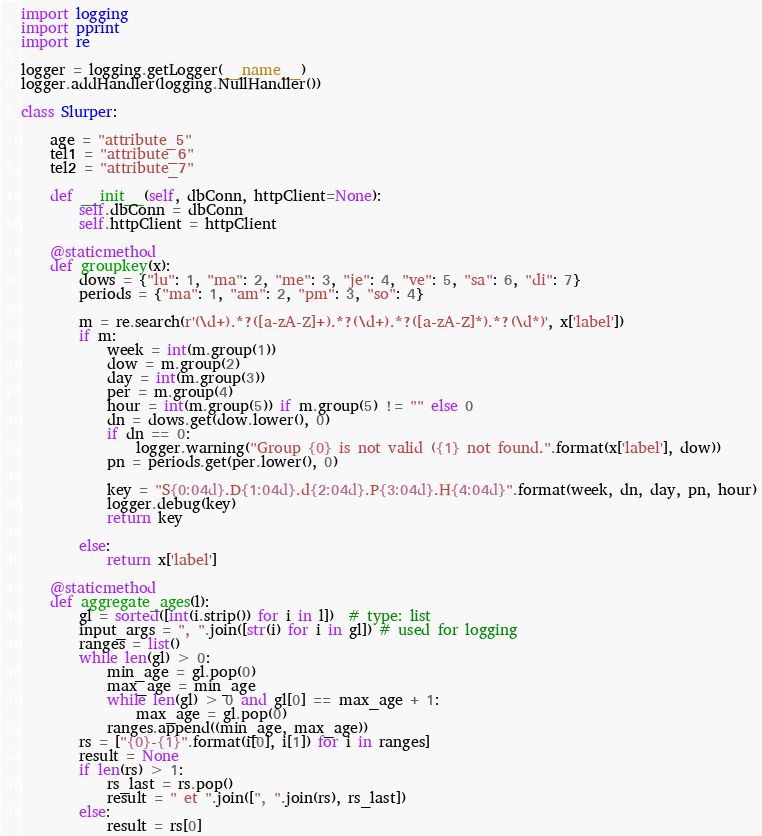Convert code to text. <code><loc_0><loc_0><loc_500><loc_500><_Python_>import logging
import pprint
import re

logger = logging.getLogger(__name__)
logger.addHandler(logging.NullHandler())

class Slurper:

    age = "attribute_5"
    tel1 = "attribute_6"
    tel2 = "attribute_7"

    def __init__(self, dbConn, httpClient=None):
        self.dbConn = dbConn
        self.httpClient = httpClient

    @staticmethod
    def groupkey(x):
        dows = {"lu": 1, "ma": 2, "me": 3, "je": 4, "ve": 5, "sa": 6, "di": 7}
        periods = {"ma": 1, "am": 2, "pm": 3, "so": 4}

        m = re.search(r'(\d+).*?([a-zA-Z]+).*?(\d+).*?([a-zA-Z]*).*?(\d*)', x['label'])
        if m:
            week = int(m.group(1))
            dow = m.group(2)
            day = int(m.group(3))
            per = m.group(4)
            hour = int(m.group(5)) if m.group(5) != "" else 0
            dn = dows.get(dow.lower(), 0)
            if dn == 0:
                logger.warning("Group {0} is not valid ({1} not found.".format(x['label'], dow))
            pn = periods.get(per.lower(), 0)

            key = "S{0:04d}.D{1:04d}.d{2:04d}.P{3:04d}.H{4:04d}".format(week, dn, day, pn, hour)
            logger.debug(key)
            return key

        else:
            return x['label']

    @staticmethod
    def aggregate_ages(l):
        gl = sorted([int(i.strip()) for i in l])  # type: list
        input_args = ", ".join([str(i) for i in gl]) # used for logging
        ranges = list()
        while len(gl) > 0:
            min_age = gl.pop(0)
            max_age = min_age
            while len(gl) > 0 and gl[0] == max_age + 1:
                max_age = gl.pop(0)
            ranges.append((min_age, max_age))
        rs = ["{0}-{1}".format(i[0], i[1]) for i in ranges]
        result = None
        if len(rs) > 1:
            rs_last = rs.pop()
            result = " et ".join([", ".join(rs), rs_last])
        else:
            result = rs[0]
</code> 